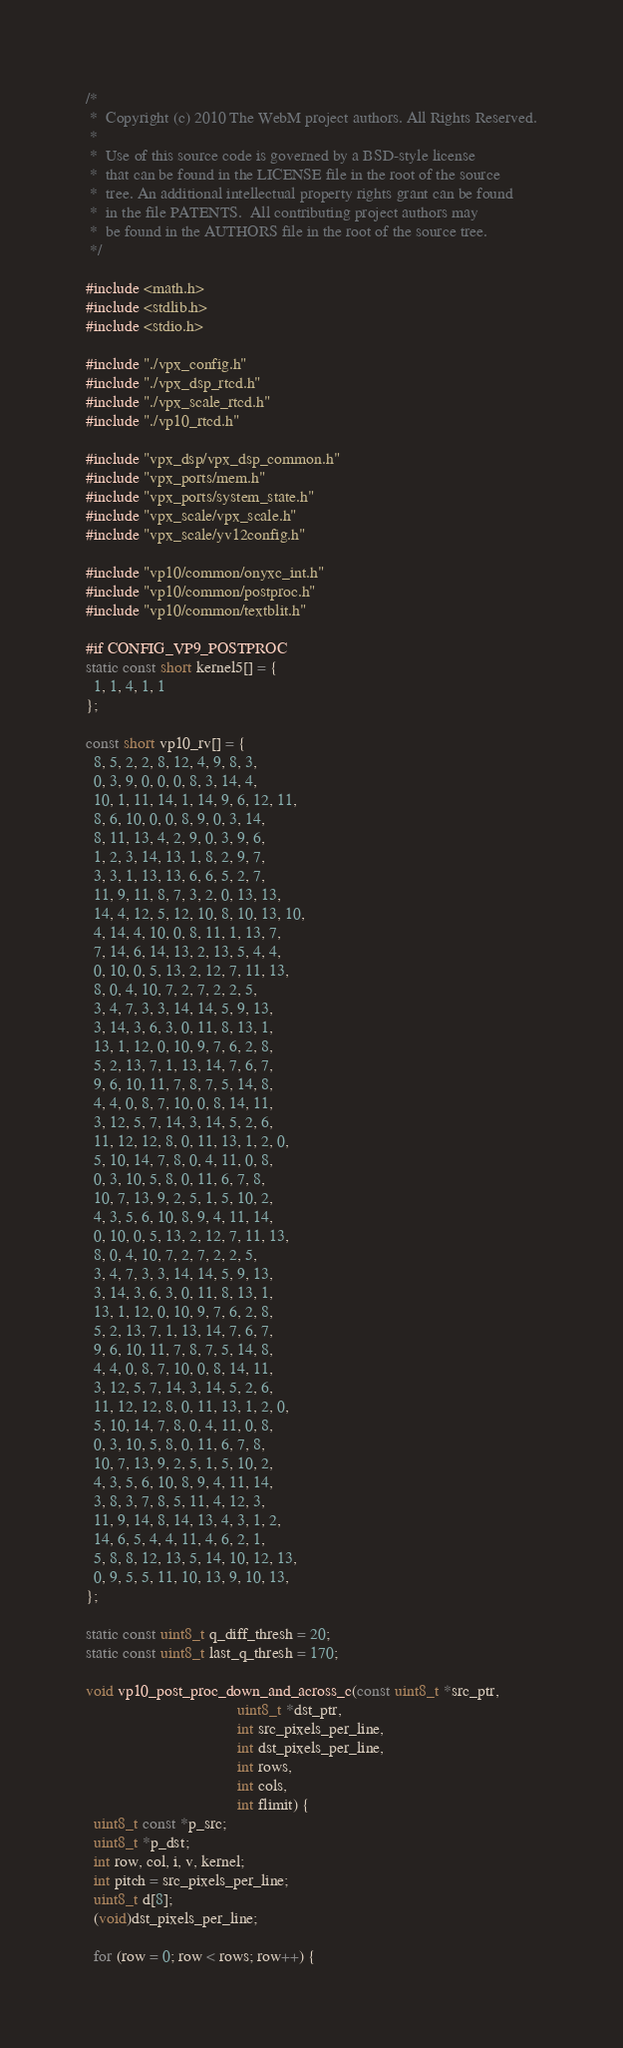<code> <loc_0><loc_0><loc_500><loc_500><_C_>/*
 *  Copyright (c) 2010 The WebM project authors. All Rights Reserved.
 *
 *  Use of this source code is governed by a BSD-style license
 *  that can be found in the LICENSE file in the root of the source
 *  tree. An additional intellectual property rights grant can be found
 *  in the file PATENTS.  All contributing project authors may
 *  be found in the AUTHORS file in the root of the source tree.
 */

#include <math.h>
#include <stdlib.h>
#include <stdio.h>

#include "./vpx_config.h"
#include "./vpx_dsp_rtcd.h"
#include "./vpx_scale_rtcd.h"
#include "./vp10_rtcd.h"

#include "vpx_dsp/vpx_dsp_common.h"
#include "vpx_ports/mem.h"
#include "vpx_ports/system_state.h"
#include "vpx_scale/vpx_scale.h"
#include "vpx_scale/yv12config.h"

#include "vp10/common/onyxc_int.h"
#include "vp10/common/postproc.h"
#include "vp10/common/textblit.h"

#if CONFIG_VP9_POSTPROC
static const short kernel5[] = {
  1, 1, 4, 1, 1
};

const short vp10_rv[] = {
  8, 5, 2, 2, 8, 12, 4, 9, 8, 3,
  0, 3, 9, 0, 0, 0, 8, 3, 14, 4,
  10, 1, 11, 14, 1, 14, 9, 6, 12, 11,
  8, 6, 10, 0, 0, 8, 9, 0, 3, 14,
  8, 11, 13, 4, 2, 9, 0, 3, 9, 6,
  1, 2, 3, 14, 13, 1, 8, 2, 9, 7,
  3, 3, 1, 13, 13, 6, 6, 5, 2, 7,
  11, 9, 11, 8, 7, 3, 2, 0, 13, 13,
  14, 4, 12, 5, 12, 10, 8, 10, 13, 10,
  4, 14, 4, 10, 0, 8, 11, 1, 13, 7,
  7, 14, 6, 14, 13, 2, 13, 5, 4, 4,
  0, 10, 0, 5, 13, 2, 12, 7, 11, 13,
  8, 0, 4, 10, 7, 2, 7, 2, 2, 5,
  3, 4, 7, 3, 3, 14, 14, 5, 9, 13,
  3, 14, 3, 6, 3, 0, 11, 8, 13, 1,
  13, 1, 12, 0, 10, 9, 7, 6, 2, 8,
  5, 2, 13, 7, 1, 13, 14, 7, 6, 7,
  9, 6, 10, 11, 7, 8, 7, 5, 14, 8,
  4, 4, 0, 8, 7, 10, 0, 8, 14, 11,
  3, 12, 5, 7, 14, 3, 14, 5, 2, 6,
  11, 12, 12, 8, 0, 11, 13, 1, 2, 0,
  5, 10, 14, 7, 8, 0, 4, 11, 0, 8,
  0, 3, 10, 5, 8, 0, 11, 6, 7, 8,
  10, 7, 13, 9, 2, 5, 1, 5, 10, 2,
  4, 3, 5, 6, 10, 8, 9, 4, 11, 14,
  0, 10, 0, 5, 13, 2, 12, 7, 11, 13,
  8, 0, 4, 10, 7, 2, 7, 2, 2, 5,
  3, 4, 7, 3, 3, 14, 14, 5, 9, 13,
  3, 14, 3, 6, 3, 0, 11, 8, 13, 1,
  13, 1, 12, 0, 10, 9, 7, 6, 2, 8,
  5, 2, 13, 7, 1, 13, 14, 7, 6, 7,
  9, 6, 10, 11, 7, 8, 7, 5, 14, 8,
  4, 4, 0, 8, 7, 10, 0, 8, 14, 11,
  3, 12, 5, 7, 14, 3, 14, 5, 2, 6,
  11, 12, 12, 8, 0, 11, 13, 1, 2, 0,
  5, 10, 14, 7, 8, 0, 4, 11, 0, 8,
  0, 3, 10, 5, 8, 0, 11, 6, 7, 8,
  10, 7, 13, 9, 2, 5, 1, 5, 10, 2,
  4, 3, 5, 6, 10, 8, 9, 4, 11, 14,
  3, 8, 3, 7, 8, 5, 11, 4, 12, 3,
  11, 9, 14, 8, 14, 13, 4, 3, 1, 2,
  14, 6, 5, 4, 4, 11, 4, 6, 2, 1,
  5, 8, 8, 12, 13, 5, 14, 10, 12, 13,
  0, 9, 5, 5, 11, 10, 13, 9, 10, 13,
};

static const uint8_t q_diff_thresh = 20;
static const uint8_t last_q_thresh = 170;

void vp10_post_proc_down_and_across_c(const uint8_t *src_ptr,
                                     uint8_t *dst_ptr,
                                     int src_pixels_per_line,
                                     int dst_pixels_per_line,
                                     int rows,
                                     int cols,
                                     int flimit) {
  uint8_t const *p_src;
  uint8_t *p_dst;
  int row, col, i, v, kernel;
  int pitch = src_pixels_per_line;
  uint8_t d[8];
  (void)dst_pixels_per_line;

  for (row = 0; row < rows; row++) {</code> 